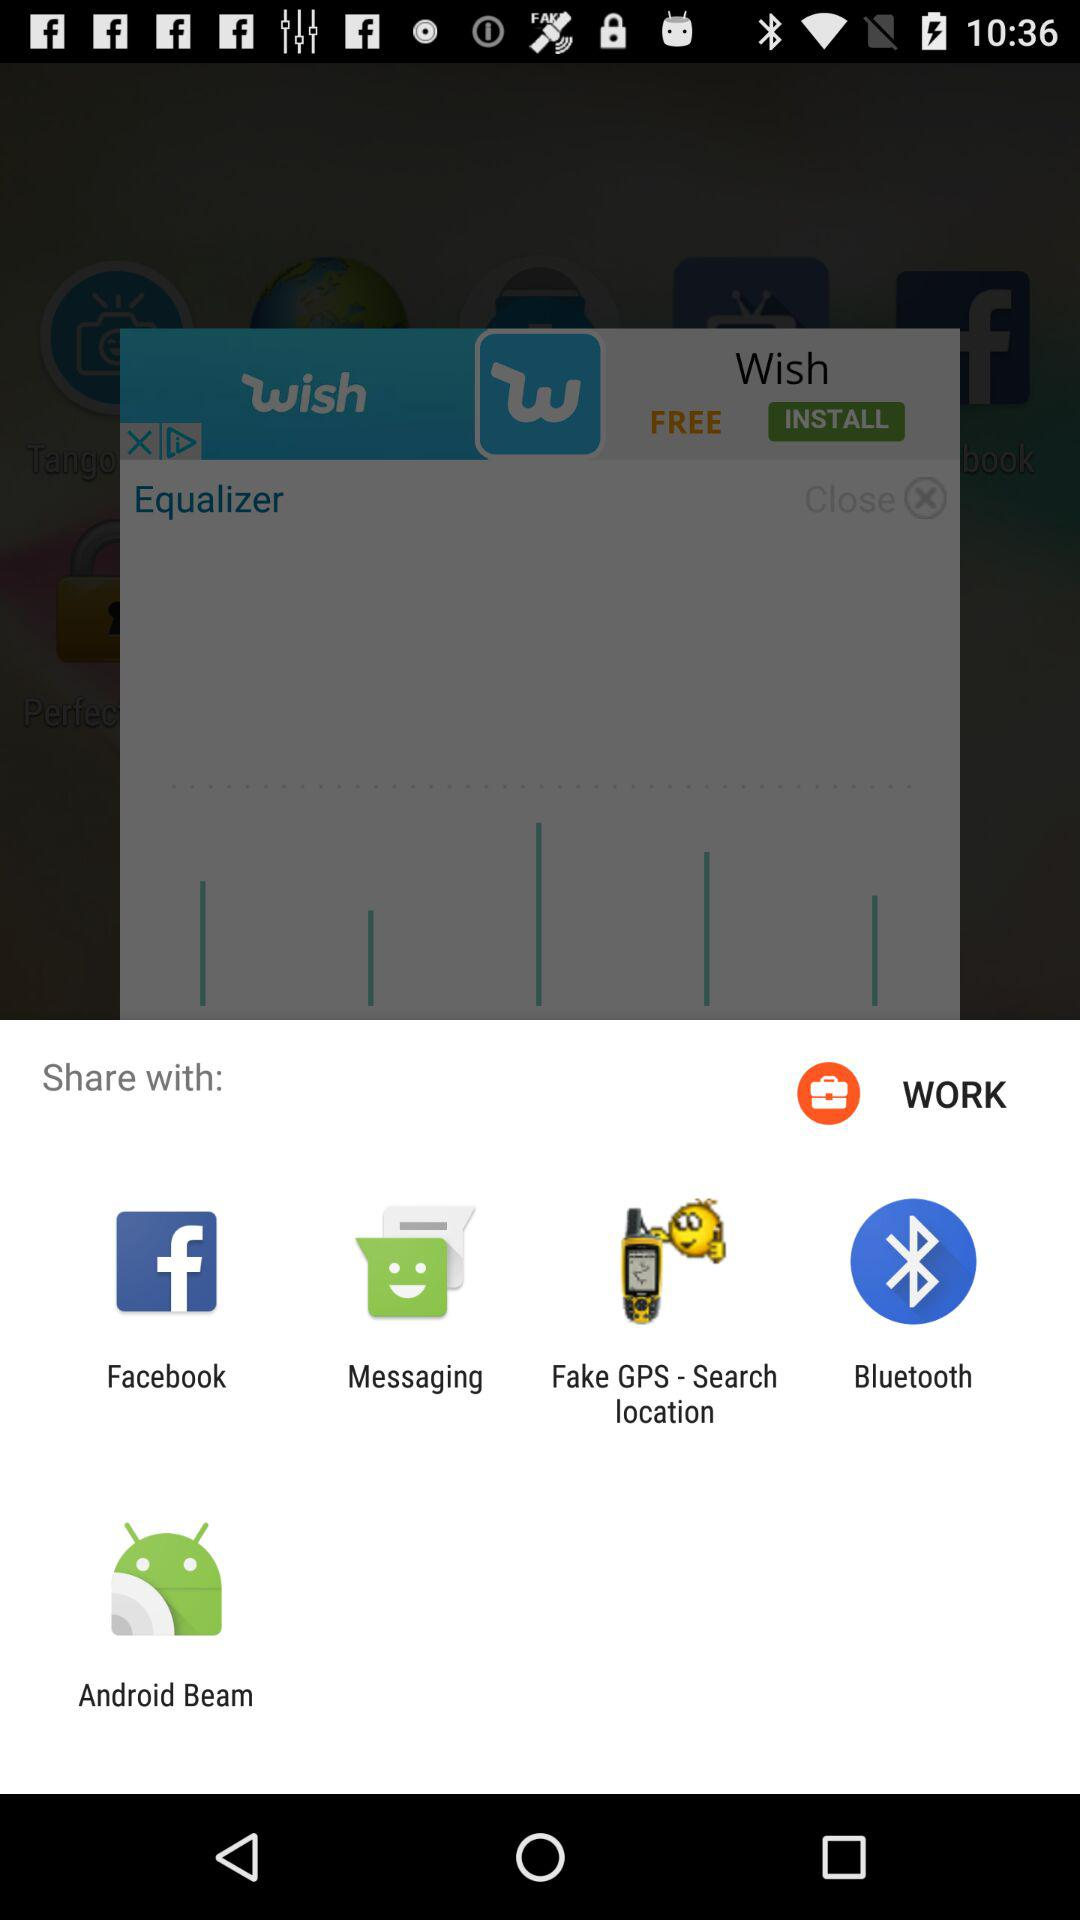Which are the different sharing options? The different sharing options are "Facebook", "Messaging", "Fake GPS - Search location", "Bluetooth" and "Android Beam". 